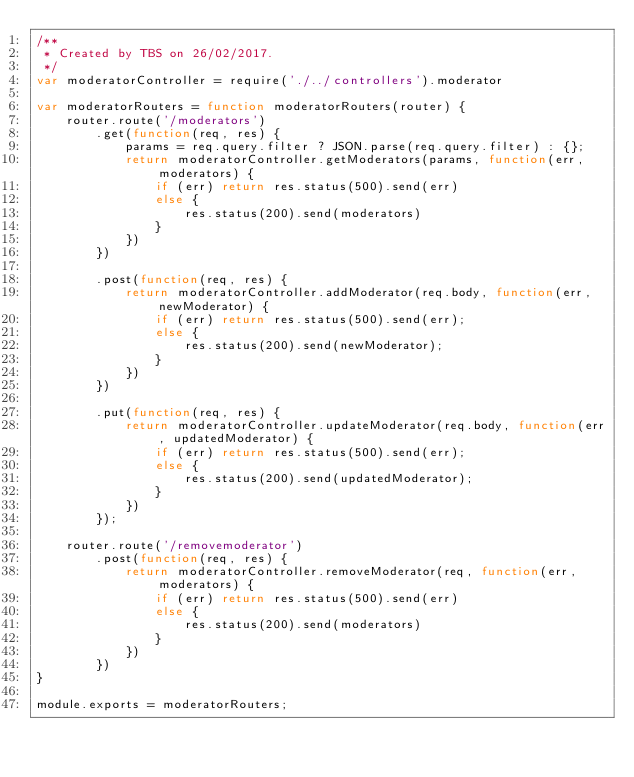Convert code to text. <code><loc_0><loc_0><loc_500><loc_500><_JavaScript_>/**
 * Created by TBS on 26/02/2017.
 */
var moderatorController = require('./../controllers').moderator

var moderatorRouters = function moderatorRouters(router) {
    router.route('/moderators')
        .get(function(req, res) {
            params = req.query.filter ? JSON.parse(req.query.filter) : {};
            return moderatorController.getModerators(params, function(err, moderators) {
                if (err) return res.status(500).send(err)
                else {
                    res.status(200).send(moderators)
                }
            })
        })

        .post(function(req, res) {
            return moderatorController.addModerator(req.body, function(err, newModerator) {
                if (err) return res.status(500).send(err);
                else {
                    res.status(200).send(newModerator);
                }
            })
        })

        .put(function(req, res) {
            return moderatorController.updateModerator(req.body, function(err, updatedModerator) {
                if (err) return res.status(500).send(err);
                else {
                    res.status(200).send(updatedModerator);
                }
            })
        });

    router.route('/removemoderator')
        .post(function(req, res) {
            return moderatorController.removeModerator(req, function(err, moderators) {
                if (err) return res.status(500).send(err)
                else {
                    res.status(200).send(moderators)
                }
            })
        })
}

module.exports = moderatorRouters;</code> 